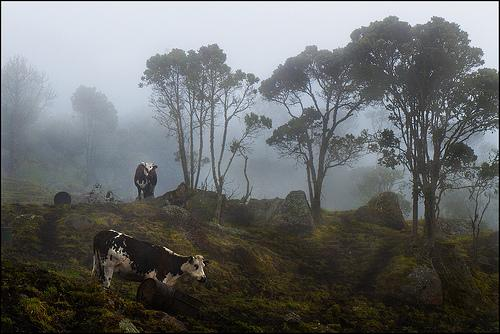Estimate the total number of cows present in the scene. Two cows. What kind of landscape does the image portray, and which objects suggest this? The image portrays a foggy, hilly landscape with sparse trees, rocks on a slope, and moss covered ground. In the given image, list three distinct objects or features that are present. A black and white cow, moss growing on a rock, and fog in the air. From the available captions, can you infer any activity or actions the cows are performing? Cows appear to be grazing, walking downhill, and standing in the fog. What type of weather condition can be observed in this image? Foggy weather condition. Mention two contrasting objects from the image and explain their appearance. A barrel on a hillside, which is brown and appears to be sitting in the moss, and a large rock on a hillside that is covered in moss and part of the green, rocky terrain. How would you assess the overall quality of the image based on the provided image? The image appears to be well-composed with clear objects and interesting elements despite the foggy weather conditions. Identify the dominant presence in the photo and provide a brief description of its location. A black and white cow is the dominant presence, standing on uneven ground in the center of a foggy, rocky hillside. What is the general atmosphere of the image given the objects and environment? A serene, foggy atmosphere in a hilly landscape with rocks and cows. What can be inferred about the interaction between cows and their environment in the image? The cows seem to be adapting and interacting well with their environment by grazing and walking on the uneven, rocky terrain of the hillside. What is growing on the large rocks in the image? moss What is the condition of the grass in the image? a) sparse, b) lush, c) withered? b) lush Identify the type of terrain the cow is standing on. uneven ground What is the weather like in the image? foggy State the type of trees present in the image. leafy on top and bare on the bottom Based on the image, where are the cows: a) inside a barn, b) in a fog-filled meadow, c) on a city street? b) in a fog-filled meadow Is there a fallen tree trunk in front of the cow? Yes Choose the correct option about the cow's position in the image: a) standing on a rock, b) walking down the hill, c) sitting on the ground. a) standing on a rock Describe the environment in the image including trees, hills, and fog. Foggy, green rocky hillside, sparse trees on the hillside, and thick fog above the tree line. How many cows are grazing in the image? two What does the barrel mentioned in the caption sit on? a hillside In the image, what is the color of the cow? black and white Describe the state of the trees on the hillside. Sparse trees with leafy tops and bare bottoms. Identify a facial feature of the cow in the image. white face What is the condition of the tree trunks in the image? skinny Which activity are the cows performing in the image? grazing 